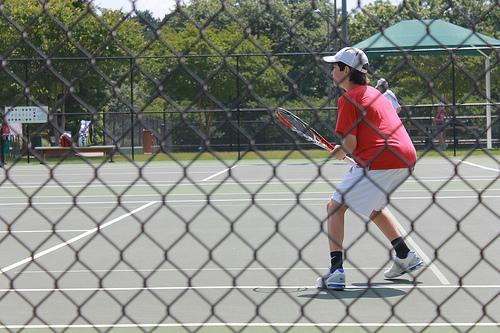Identify the main person's clothing and accessories in the scene. The main person is wearing a red shirt, white shorts, black calf-length socks, white and blue shoes, and a white cap. Tell me what the prominent figure is doing in the picture? The person in focus is playing tennis, wearing a red t-shirt, white cap, and holding a tennis racquet. Tell me about the type of location this sport is happening? The sport is happening in a tennis court surrounded by a black chain-link fence. Describe the footwear of the person playing tennis in the image. The person playing tennis is wearing white sneakers with blue trim. What is the color of the shirt worn by the tennis player? The tennis player is wearing a red shirt. What activity is the person with red shirt participating in? The person wearing a red shirt is playing tennis. Describe the key elements of the individual's outfit in the image. The person in the image is wearing a red shirt, white shorts, black socks, white and blue shoes, and a white cap. What kind of headgear is the tennis player wearing? The tennis player is wearing a white cap. What type of tennis racquet is the player holding? The player is holding a red and white tennis racquet. What is the primary object in the image and its significant activity? A man wearing a red shirt, white cap, and holding a tennis racquet is playing in a tennis court. 